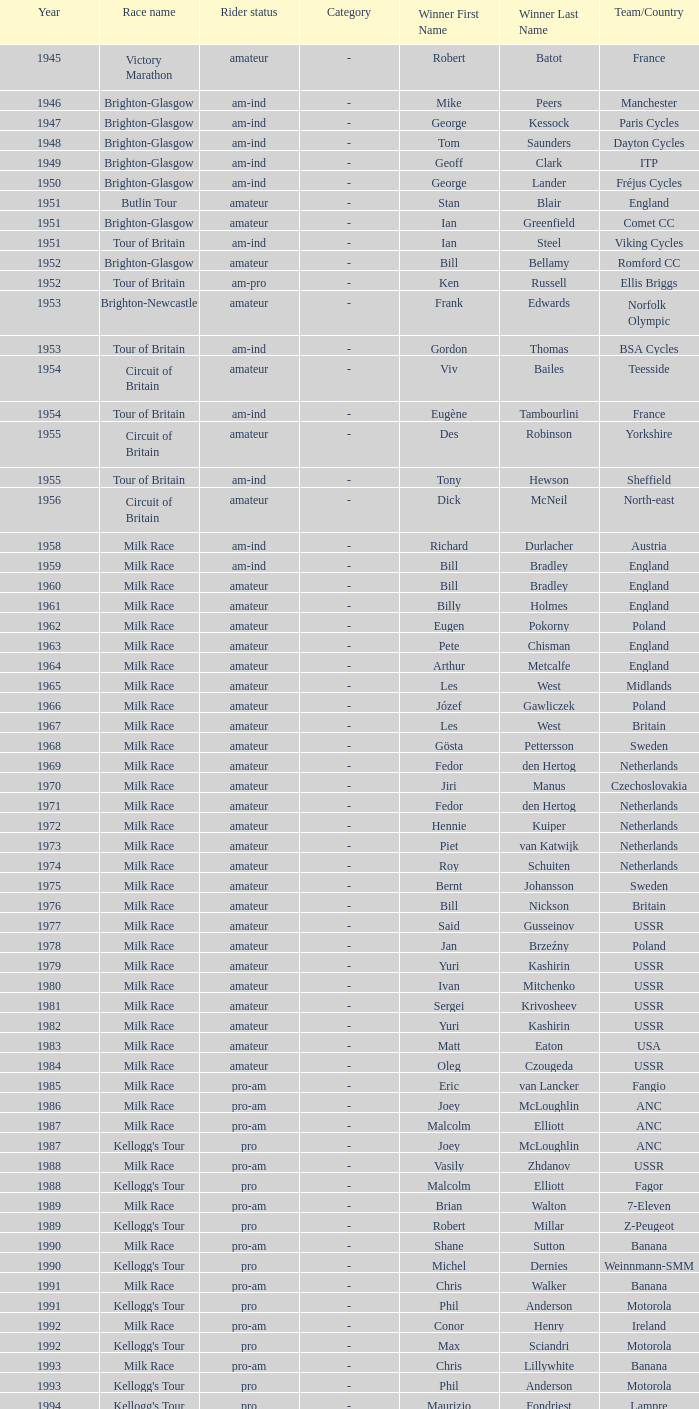Could you parse the entire table? {'header': ['Year', 'Race name', 'Rider status', 'Category', 'Winner First Name', 'Winner Last Name', 'Team/Country'], 'rows': [['1945', 'Victory Marathon', 'amateur', '-', 'Robert', 'Batot', 'France'], ['1946', 'Brighton-Glasgow', 'am-ind', '-', 'Mike', 'Peers', 'Manchester'], ['1947', 'Brighton-Glasgow', 'am-ind', '-', 'George', 'Kessock', 'Paris Cycles'], ['1948', 'Brighton-Glasgow', 'am-ind', '-', 'Tom', 'Saunders', 'Dayton Cycles'], ['1949', 'Brighton-Glasgow', 'am-ind', '-', 'Geoff', 'Clark', 'ITP'], ['1950', 'Brighton-Glasgow', 'am-ind', '-', 'George', 'Lander', 'Fréjus Cycles'], ['1951', 'Butlin Tour', 'amateur', '-', 'Stan', 'Blair', 'England'], ['1951', 'Brighton-Glasgow', 'amateur', '-', 'Ian', 'Greenfield', 'Comet CC'], ['1951', 'Tour of Britain', 'am-ind', '-', 'Ian', 'Steel', 'Viking Cycles'], ['1952', 'Brighton-Glasgow', 'amateur', '-', 'Bill', 'Bellamy', 'Romford CC'], ['1952', 'Tour of Britain', 'am-pro', '-', 'Ken', 'Russell', 'Ellis Briggs'], ['1953', 'Brighton-Newcastle', 'amateur', '-', 'Frank', 'Edwards', 'Norfolk Olympic'], ['1953', 'Tour of Britain', 'am-ind', '-', 'Gordon', 'Thomas', 'BSA Cycles'], ['1954', 'Circuit of Britain', 'amateur', '-', 'Viv', 'Bailes', 'Teesside'], ['1954', 'Tour of Britain', 'am-ind', '-', 'Eugène', 'Tambourlini', 'France'], ['1955', 'Circuit of Britain', 'amateur', '-', 'Des', 'Robinson', 'Yorkshire'], ['1955', 'Tour of Britain', 'am-ind', '-', 'Tony', 'Hewson', 'Sheffield'], ['1956', 'Circuit of Britain', 'amateur', '-', 'Dick', 'McNeil', 'North-east'], ['1958', 'Milk Race', 'am-ind', '-', 'Richard', 'Durlacher', 'Austria'], ['1959', 'Milk Race', 'am-ind', '-', 'Bill', 'Bradley', 'England'], ['1960', 'Milk Race', 'amateur', '-', 'Bill', 'Bradley', 'England'], ['1961', 'Milk Race', 'amateur', '-', 'Billy', 'Holmes', 'England'], ['1962', 'Milk Race', 'amateur', '-', 'Eugen', 'Pokorny', 'Poland'], ['1963', 'Milk Race', 'amateur', '-', 'Pete', 'Chisman', 'England'], ['1964', 'Milk Race', 'amateur', '-', 'Arthur', 'Metcalfe', 'England'], ['1965', 'Milk Race', 'amateur', '-', 'Les', 'West', 'Midlands'], ['1966', 'Milk Race', 'amateur', '-', 'Józef', 'Gawliczek', 'Poland'], ['1967', 'Milk Race', 'amateur', '-', 'Les', 'West', 'Britain'], ['1968', 'Milk Race', 'amateur', '-', 'Gösta', 'Pettersson', 'Sweden'], ['1969', 'Milk Race', 'amateur', '-', 'Fedor', 'den Hertog', 'Netherlands'], ['1970', 'Milk Race', 'amateur', '-', 'Jiri', 'Manus', 'Czechoslovakia'], ['1971', 'Milk Race', 'amateur', '-', 'Fedor', 'den Hertog', 'Netherlands'], ['1972', 'Milk Race', 'amateur', '-', 'Hennie', 'Kuiper', 'Netherlands'], ['1973', 'Milk Race', 'amateur', '-', 'Piet', 'van Katwijk', 'Netherlands'], ['1974', 'Milk Race', 'amateur', '-', 'Roy', 'Schuiten', 'Netherlands'], ['1975', 'Milk Race', 'amateur', '-', 'Bernt', 'Johansson', 'Sweden'], ['1976', 'Milk Race', 'amateur', '-', 'Bill', 'Nickson', 'Britain'], ['1977', 'Milk Race', 'amateur', '-', 'Said', 'Gusseinov', 'USSR'], ['1978', 'Milk Race', 'amateur', '-', 'Jan', 'Brzeźny', 'Poland'], ['1979', 'Milk Race', 'amateur', '-', 'Yuri', 'Kashirin', 'USSR'], ['1980', 'Milk Race', 'amateur', '-', 'Ivan', 'Mitchenko', 'USSR'], ['1981', 'Milk Race', 'amateur', '-', 'Sergei', 'Krivosheev', 'USSR'], ['1982', 'Milk Race', 'amateur', '-', 'Yuri', 'Kashirin', 'USSR'], ['1983', 'Milk Race', 'amateur', '-', 'Matt', 'Eaton', 'USA'], ['1984', 'Milk Race', 'amateur', '-', 'Oleg', 'Czougeda', 'USSR'], ['1985', 'Milk Race', 'pro-am', '-', 'Eric', 'van Lancker', 'Fangio'], ['1986', 'Milk Race', 'pro-am', '-', 'Joey', 'McLoughlin', 'ANC'], ['1987', 'Milk Race', 'pro-am', '-', 'Malcolm', 'Elliott', 'ANC'], ['1987', "Kellogg's Tour", 'pro', '-', 'Joey', 'McLoughlin', 'ANC'], ['1988', 'Milk Race', 'pro-am', '-', 'Vasily', 'Zhdanov', 'USSR'], ['1988', "Kellogg's Tour", 'pro', '-', 'Malcolm', 'Elliott', 'Fagor'], ['1989', 'Milk Race', 'pro-am', '-', 'Brian', 'Walton', '7-Eleven'], ['1989', "Kellogg's Tour", 'pro', '-', 'Robert', 'Millar', 'Z-Peugeot'], ['1990', 'Milk Race', 'pro-am', '-', 'Shane', 'Sutton', 'Banana'], ['1990', "Kellogg's Tour", 'pro', '-', 'Michel', 'Dernies', 'Weinnmann-SMM'], ['1991', 'Milk Race', 'pro-am', '-', 'Chris', 'Walker', 'Banana'], ['1991', "Kellogg's Tour", 'pro', '-', 'Phil', 'Anderson', 'Motorola'], ['1992', 'Milk Race', 'pro-am', '-', 'Conor', 'Henry', 'Ireland'], ['1992', "Kellogg's Tour", 'pro', '-', 'Max', 'Sciandri', 'Motorola'], ['1993', 'Milk Race', 'pro-am', '-', 'Chris', 'Lillywhite', 'Banana'], ['1993', "Kellogg's Tour", 'pro', '-', 'Phil', 'Anderson', 'Motorola'], ['1994', "Kellogg's Tour", 'pro', '-', 'Maurizio', 'Fondriest', 'Lampre'], ['1998', 'PruTour', 'pro', '-', 'Stuart', "O'Grady", 'Crédit Agricole'], ['1999', 'PruTour', 'pro', '-', 'Marc', 'Wauters', 'Rabobank']]} Who was the winner in 1973 with an amateur rider status? Piet van Katwijk. 